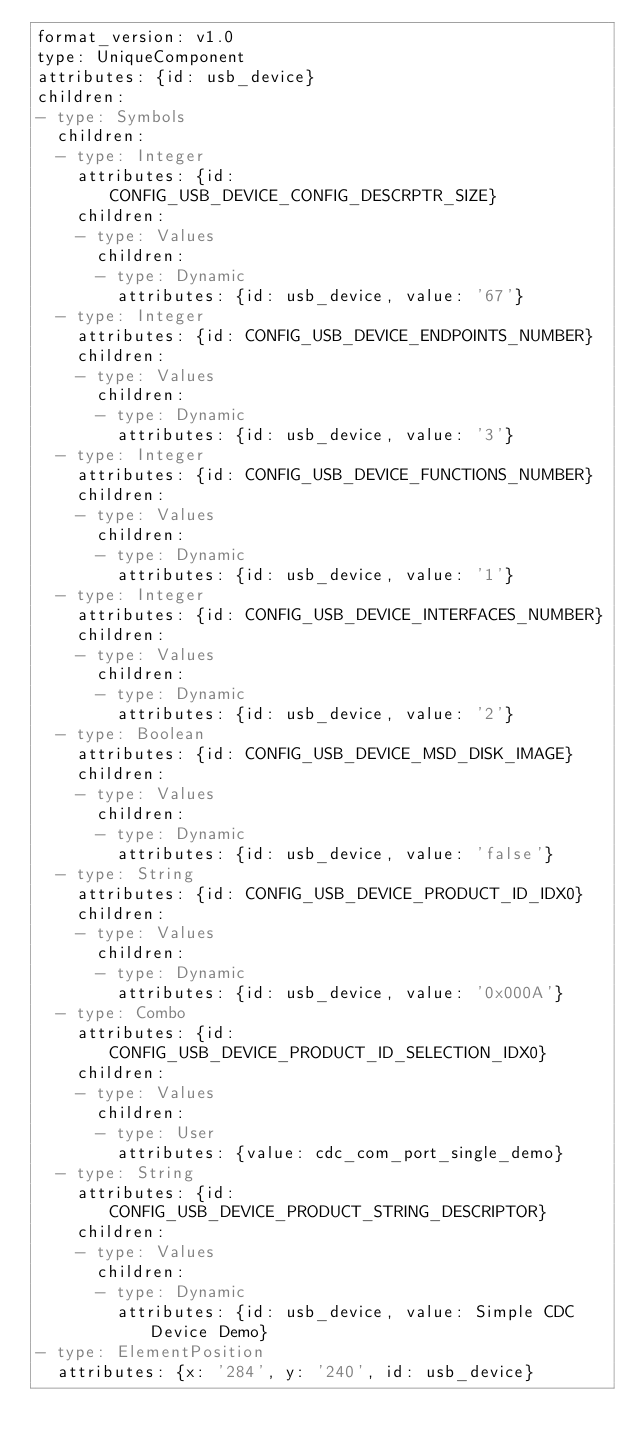Convert code to text. <code><loc_0><loc_0><loc_500><loc_500><_YAML_>format_version: v1.0
type: UniqueComponent
attributes: {id: usb_device}
children:
- type: Symbols
  children:
  - type: Integer
    attributes: {id: CONFIG_USB_DEVICE_CONFIG_DESCRPTR_SIZE}
    children:
    - type: Values
      children:
      - type: Dynamic
        attributes: {id: usb_device, value: '67'}
  - type: Integer
    attributes: {id: CONFIG_USB_DEVICE_ENDPOINTS_NUMBER}
    children:
    - type: Values
      children:
      - type: Dynamic
        attributes: {id: usb_device, value: '3'}
  - type: Integer
    attributes: {id: CONFIG_USB_DEVICE_FUNCTIONS_NUMBER}
    children:
    - type: Values
      children:
      - type: Dynamic
        attributes: {id: usb_device, value: '1'}
  - type: Integer
    attributes: {id: CONFIG_USB_DEVICE_INTERFACES_NUMBER}
    children:
    - type: Values
      children:
      - type: Dynamic
        attributes: {id: usb_device, value: '2'}
  - type: Boolean
    attributes: {id: CONFIG_USB_DEVICE_MSD_DISK_IMAGE}
    children:
    - type: Values
      children:
      - type: Dynamic
        attributes: {id: usb_device, value: 'false'}
  - type: String
    attributes: {id: CONFIG_USB_DEVICE_PRODUCT_ID_IDX0}
    children:
    - type: Values
      children:
      - type: Dynamic
        attributes: {id: usb_device, value: '0x000A'}
  - type: Combo
    attributes: {id: CONFIG_USB_DEVICE_PRODUCT_ID_SELECTION_IDX0}
    children:
    - type: Values
      children:
      - type: User
        attributes: {value: cdc_com_port_single_demo}
  - type: String
    attributes: {id: CONFIG_USB_DEVICE_PRODUCT_STRING_DESCRIPTOR}
    children:
    - type: Values
      children:
      - type: Dynamic
        attributes: {id: usb_device, value: Simple CDC Device Demo}
- type: ElementPosition
  attributes: {x: '284', y: '240', id: usb_device}
</code> 